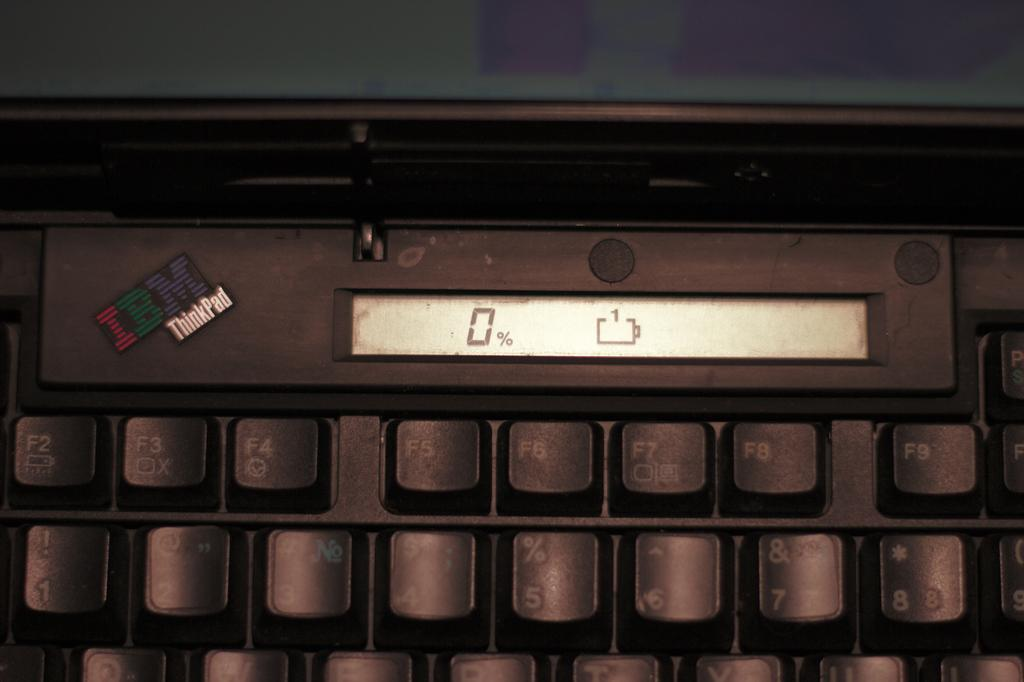Provide a one-sentence caption for the provided image. IBM Thinkpad keyboard that shows 0% and no battery. 